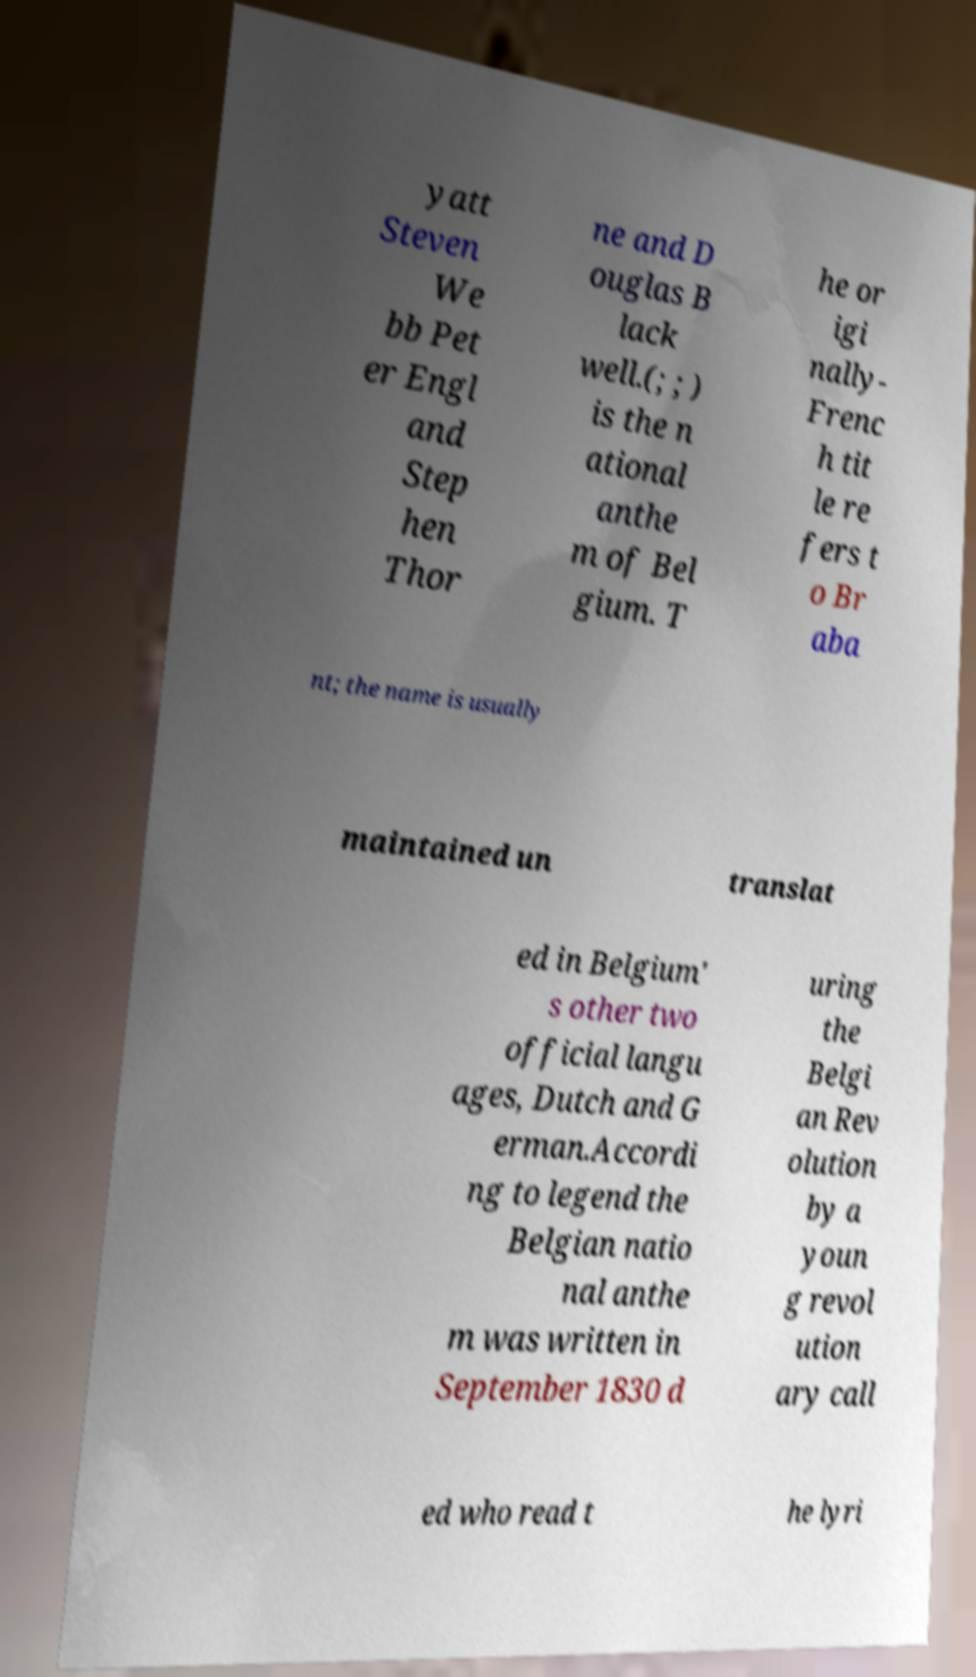For documentation purposes, I need the text within this image transcribed. Could you provide that? yatt Steven We bb Pet er Engl and Step hen Thor ne and D ouglas B lack well.(; ; ) is the n ational anthe m of Bel gium. T he or igi nally- Frenc h tit le re fers t o Br aba nt; the name is usually maintained un translat ed in Belgium' s other two official langu ages, Dutch and G erman.Accordi ng to legend the Belgian natio nal anthe m was written in September 1830 d uring the Belgi an Rev olution by a youn g revol ution ary call ed who read t he lyri 